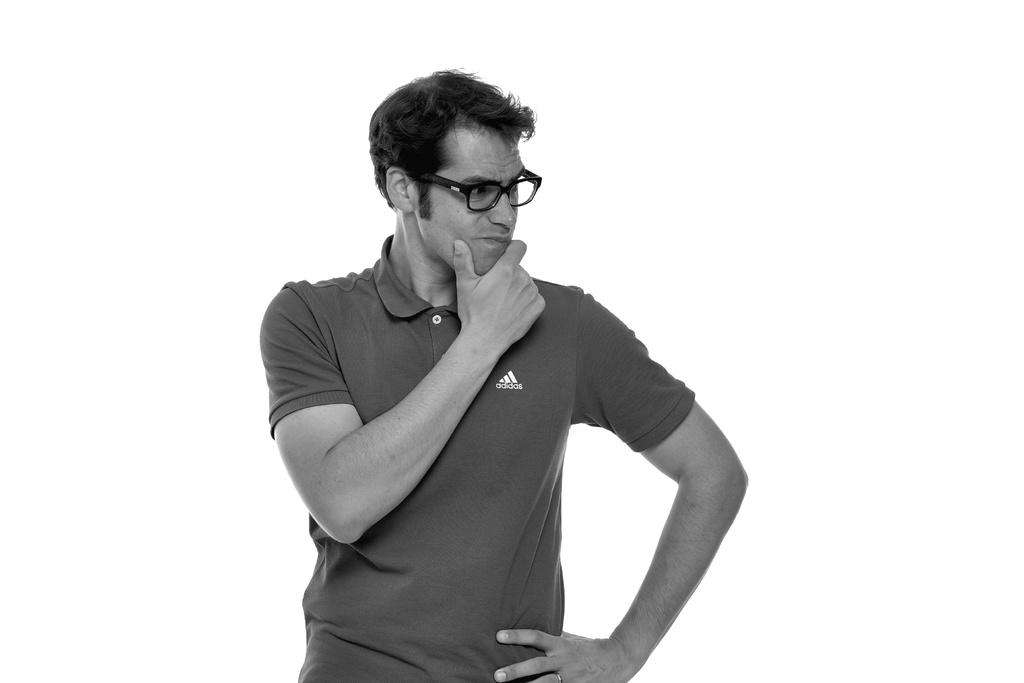What is the main subject of the image? There is a person standing in the image. Can you describe the person's appearance? The person is wearing spectacles. What is the color scheme of the image? The image is in black and white. What type of metal can be seen in the person's hand in the image? There is no metal visible in the person's hand in the image. 